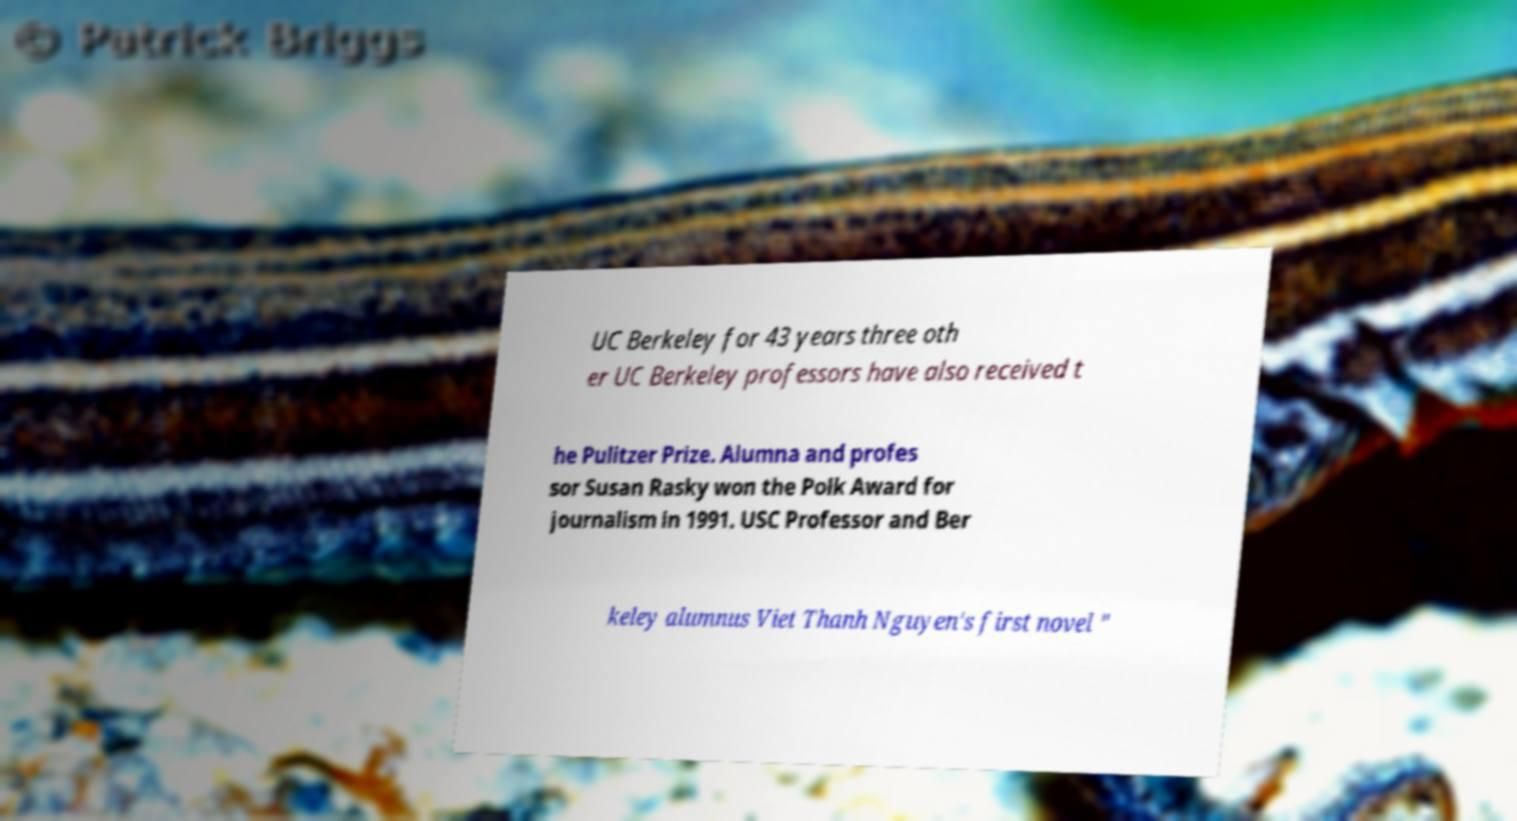Please read and relay the text visible in this image. What does it say? UC Berkeley for 43 years three oth er UC Berkeley professors have also received t he Pulitzer Prize. Alumna and profes sor Susan Rasky won the Polk Award for journalism in 1991. USC Professor and Ber keley alumnus Viet Thanh Nguyen's first novel " 